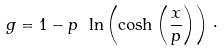<formula> <loc_0><loc_0><loc_500><loc_500>g = 1 - p \ { \ln } \left ( \cosh \left ( \frac { x } { p } \right ) \right ) \, \cdot</formula> 